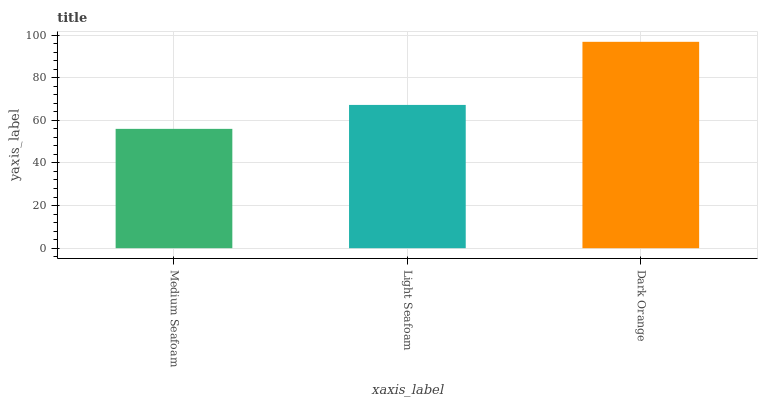Is Medium Seafoam the minimum?
Answer yes or no. Yes. Is Dark Orange the maximum?
Answer yes or no. Yes. Is Light Seafoam the minimum?
Answer yes or no. No. Is Light Seafoam the maximum?
Answer yes or no. No. Is Light Seafoam greater than Medium Seafoam?
Answer yes or no. Yes. Is Medium Seafoam less than Light Seafoam?
Answer yes or no. Yes. Is Medium Seafoam greater than Light Seafoam?
Answer yes or no. No. Is Light Seafoam less than Medium Seafoam?
Answer yes or no. No. Is Light Seafoam the high median?
Answer yes or no. Yes. Is Light Seafoam the low median?
Answer yes or no. Yes. Is Medium Seafoam the high median?
Answer yes or no. No. Is Dark Orange the low median?
Answer yes or no. No. 